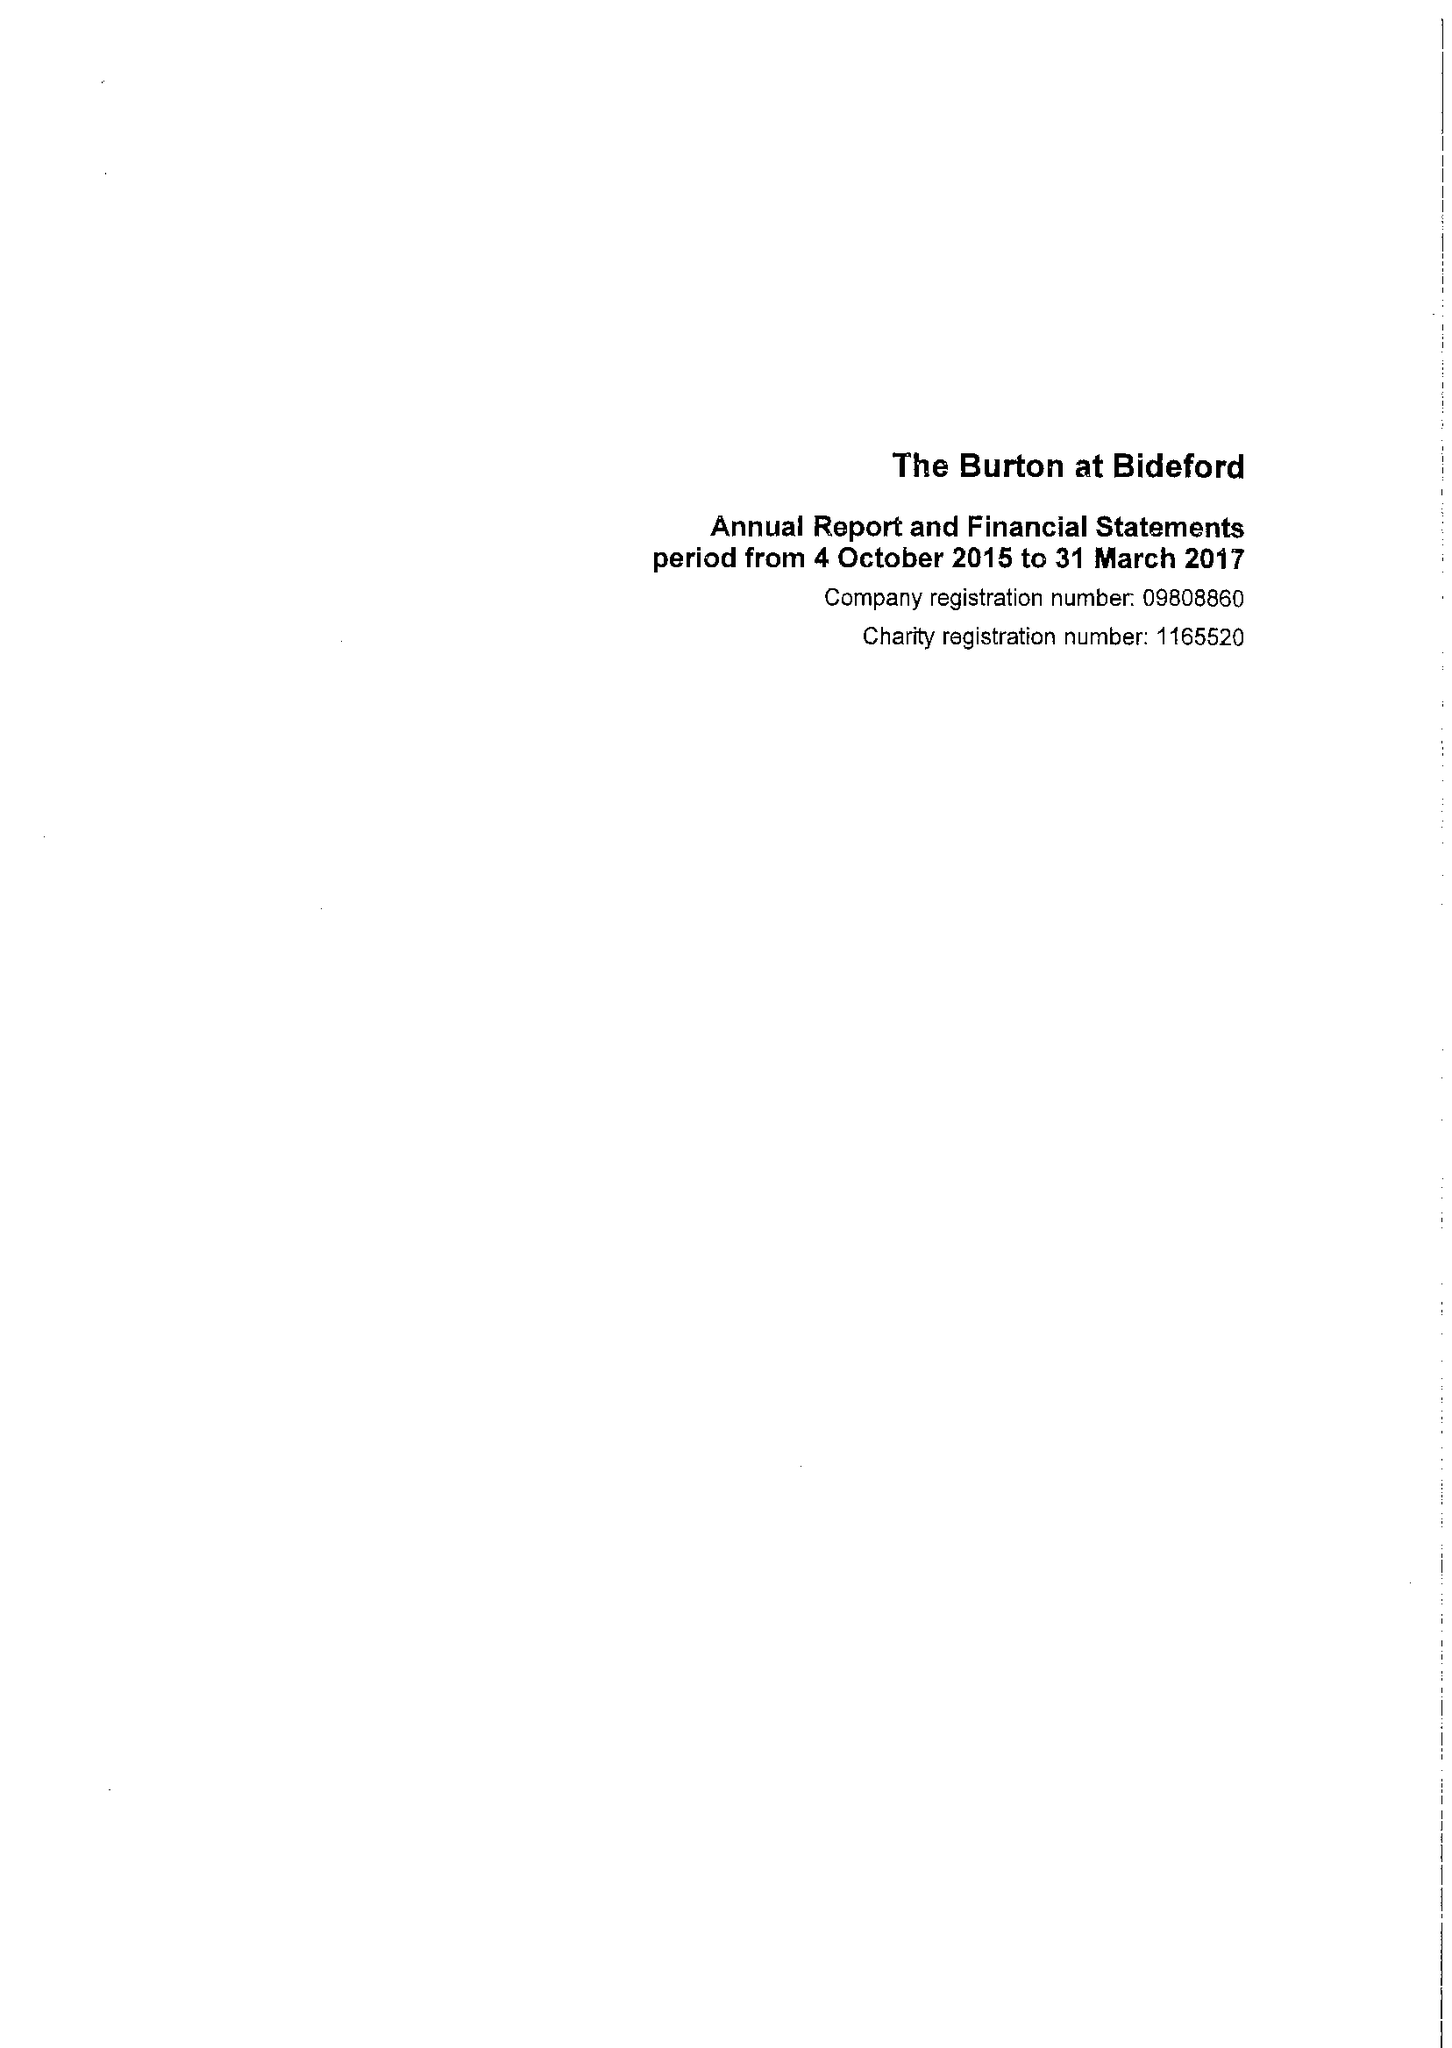What is the value for the charity_name?
Answer the question using a single word or phrase. The Burton At Bideford 